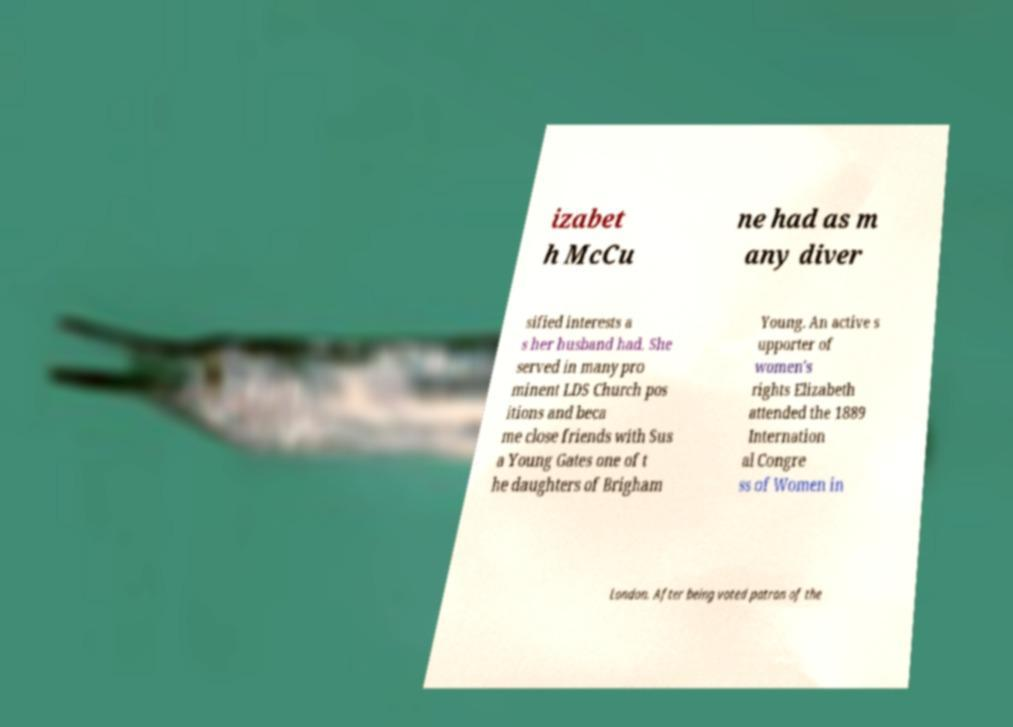Please identify and transcribe the text found in this image. izabet h McCu ne had as m any diver sified interests a s her husband had. She served in many pro minent LDS Church pos itions and beca me close friends with Sus a Young Gates one of t he daughters of Brigham Young. An active s upporter of women's rights Elizabeth attended the 1889 Internation al Congre ss of Women in London. After being voted patron of the 